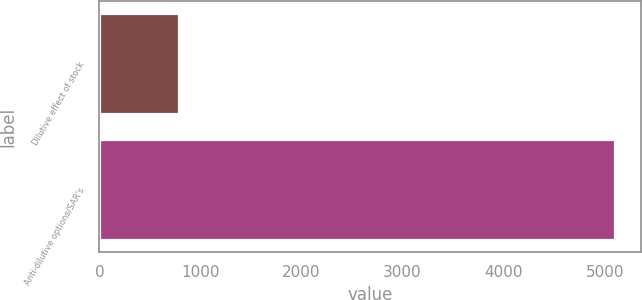Convert chart to OTSL. <chart><loc_0><loc_0><loc_500><loc_500><bar_chart><fcel>Dilutive effect of stock<fcel>Anti-dilutive options/SAR's<nl><fcel>788<fcel>5103<nl></chart> 